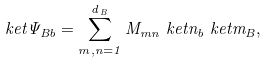<formula> <loc_0><loc_0><loc_500><loc_500>\ k e t { \Psi } _ { B b } = \sum _ { m , n = 1 } ^ { d _ { \, B } } M _ { m n } \ k e t { n } _ { b } \ k e t { m } _ { B } ,</formula> 